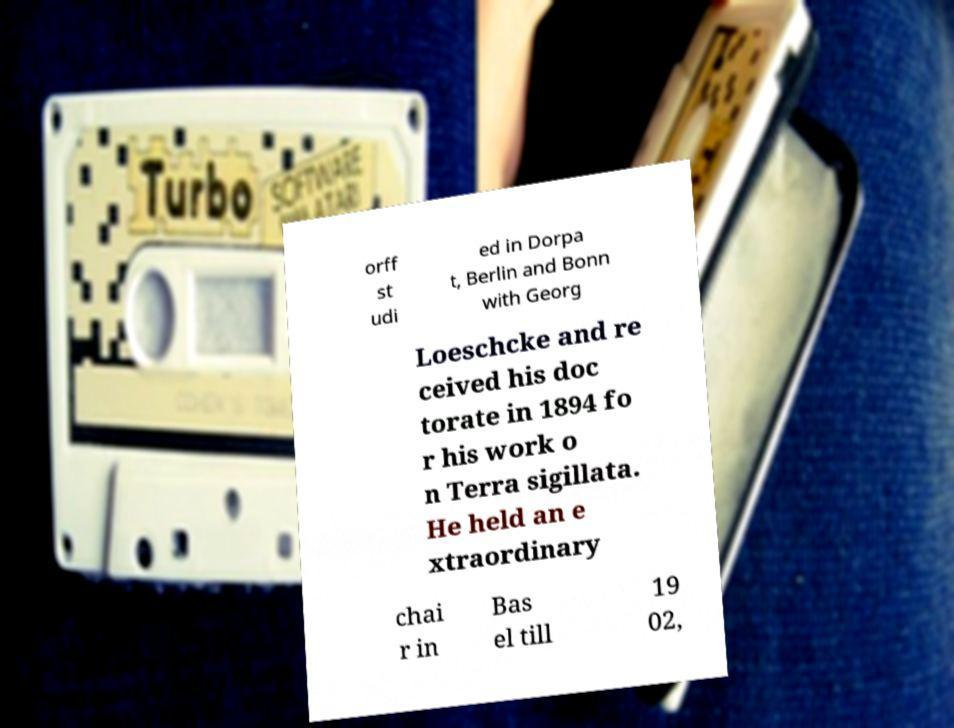For documentation purposes, I need the text within this image transcribed. Could you provide that? orff st udi ed in Dorpa t, Berlin and Bonn with Georg Loeschcke and re ceived his doc torate in 1894 fo r his work o n Terra sigillata. He held an e xtraordinary chai r in Bas el till 19 02, 